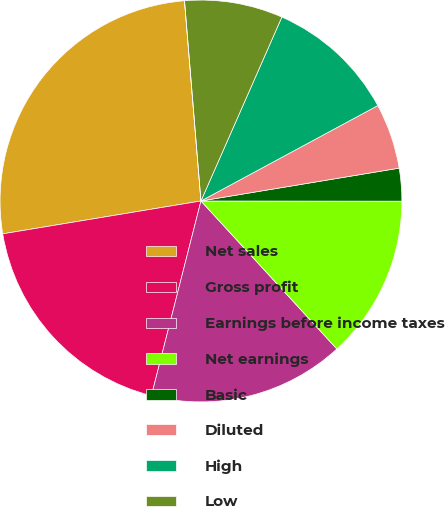Convert chart to OTSL. <chart><loc_0><loc_0><loc_500><loc_500><pie_chart><fcel>Net sales<fcel>Gross profit<fcel>Earnings before income taxes<fcel>Net earnings<fcel>Basic<fcel>Diluted<fcel>High<fcel>Low<fcel>Dividends declared per share<nl><fcel>26.31%<fcel>18.42%<fcel>15.79%<fcel>13.16%<fcel>2.63%<fcel>5.26%<fcel>10.53%<fcel>7.9%<fcel>0.0%<nl></chart> 